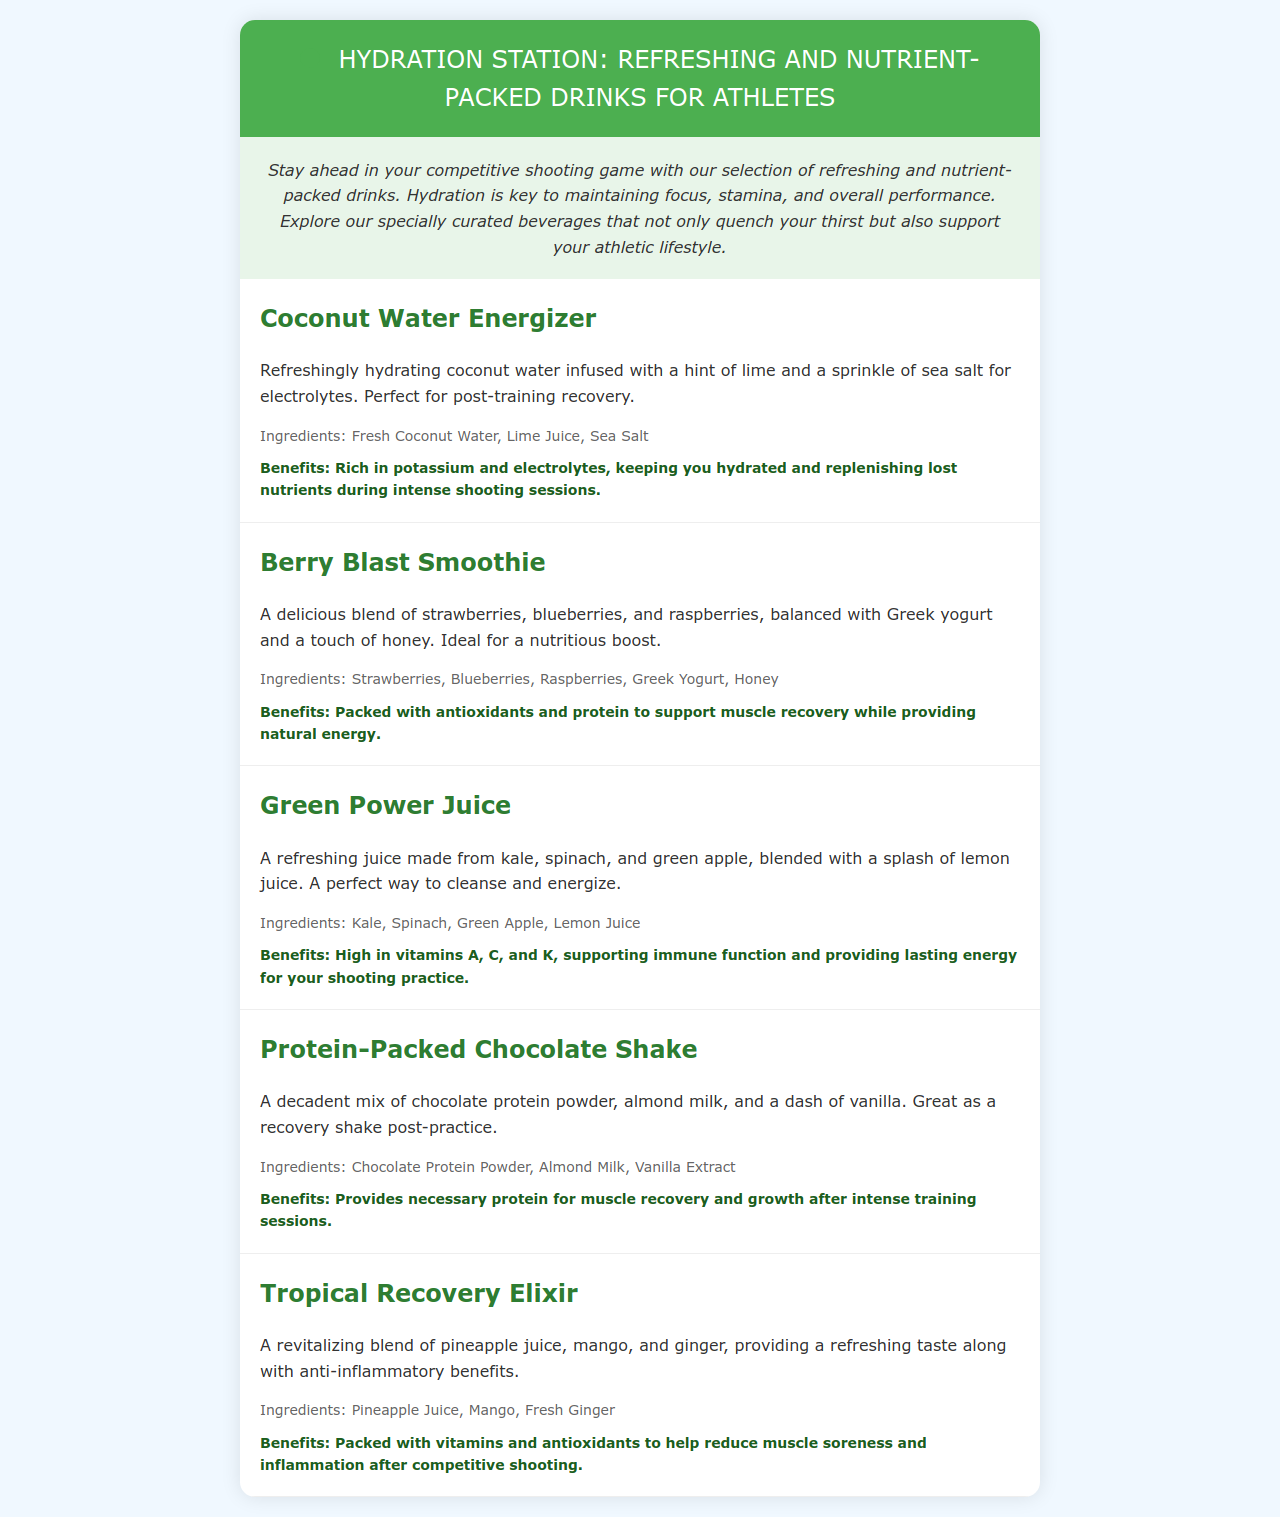What is the first drink listed on the menu? The first drink listed is the "Coconut Water Energizer."
Answer: Coconut Water Energizer What ingredients are in the Berry Blast Smoothie? The ingredients are strawberries, blueberries, raspberries, Greek yogurt, and honey.
Answer: Strawberries, Blueberries, Raspberries, Greek Yogurt, Honey What are the benefits of the Tropical Recovery Elixir? The benefits include being packed with vitamins and antioxidants to help reduce muscle soreness and inflammation.
Answer: Packed with vitamins and antioxidants to help reduce muscle soreness and inflammation Which drink is described as being high in vitamins A, C, and K? The "Green Power Juice" is described as high in vitamins A, C, and K.
Answer: Green Power Juice How many drinks are listed on the menu? There are a total of five drinks listed in the menu.
Answer: Five What type of milk is used in the Protein-Packed Chocolate Shake? The shake uses almond milk as one of its ingredients.
Answer: Almond Milk What flavor does the Coconut Water Energizer have alongside coconut? It has a hint of lime for flavor.
Answer: Hint of lime What is the purpose of hydration mentioned in the introduction? Hydration is key to maintaining focus, stamina, and overall performance in competitive shooting.
Answer: Maintaining focus, stamina, and overall performance 